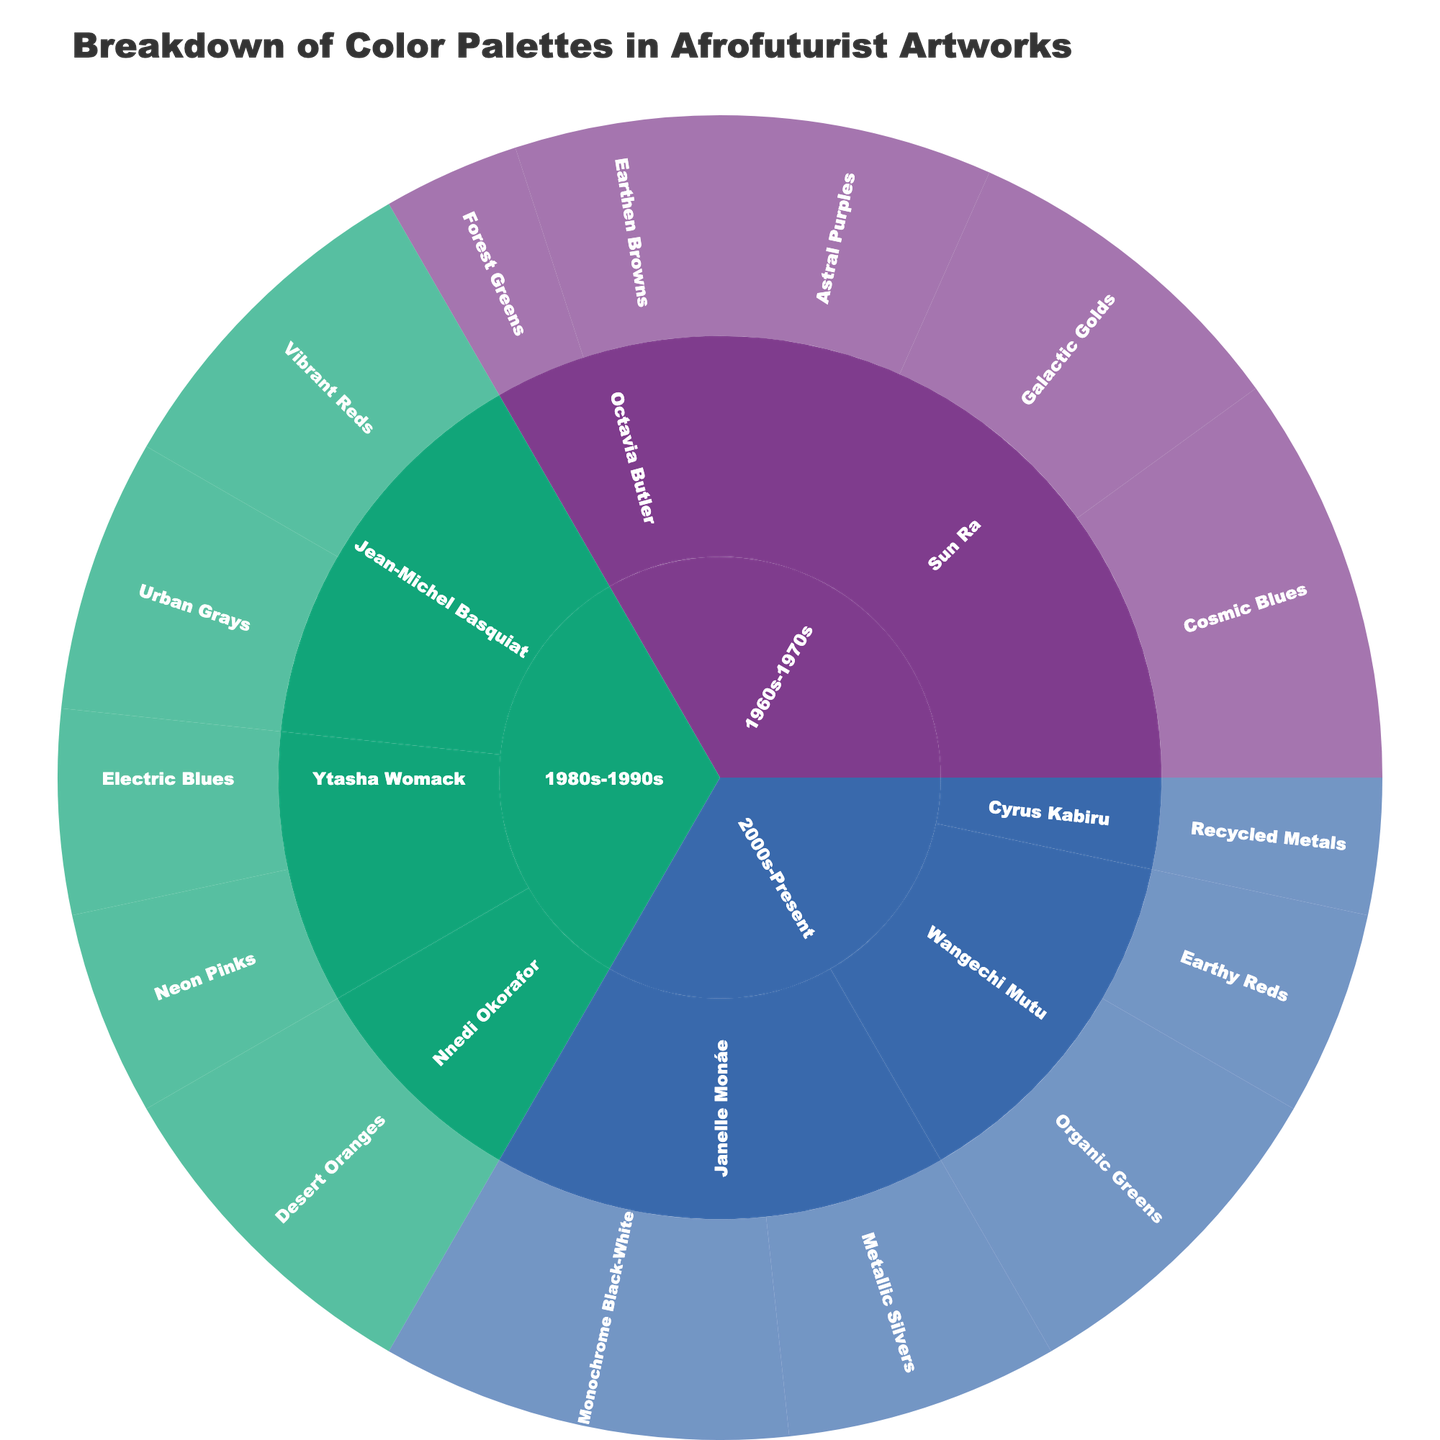What is the title of the figure? The title of the figure appears at the top, and it generally summarizes the main subject of the data visualization. The title reads "Breakdown of Color Palettes in Afrofuturist Artworks".
Answer: Breakdown of Color Palettes in Afrofuturist Artworks Which era has the highest percentage for any single color palette, and what is that percentage? By examining the sunburst plot, we see that the era 2000s-Present with the "Janelle Monáe" influence and "Monochrome Black-White" color palette has the highest percentage, which is 30%.
Answer: 2000s-Present, 30% How many influences contributed color palettes in the 1980s-1990s era? By observing the different sections of the sunburst plot corresponding to 1980s-1990s, we count the distinct influences listed. There are Jean-Michel Basquiat, Ytasha Womack, and Nnedi Okorafor, making it a total of 3.
Answer: 3 What is the combined percentage of the color palettes influenced by Sun Ra in the 1960s-1970s era? From the sunburst plot, we identify the color palettes under Sun Ra for the 1960s-1970s era: Cosmic Blues (30%), Galactic Golds (25%), and Astral Purples (20%). Adding these percentages gives 30 + 25 + 20 = 75%.
Answer: 75% Compare the total percentage of color palettes influenced by Janelle Monáe and Wangechi Mutu in the 2000s-Present era. Which one has a higher total percentage and by how much? For Janelle Monáe: Monochrome Black-White (30%) + Metallic Silvers (20%) = 50%. For Wangechi Mutu: Organic Greens (25%) + Earthy Reds (15%) = 40%. Janelle Monáe has a higher total percentage, with a difference of 50 - 40 = 10%.
Answer: Janelle Monáe, 10% What is the most commonly used color palette in Afrofuturist artworks according to the figure? By reviewing the color palette percentages across all eras and influences, the most frequently occurring color palette with the highest single percentage is "Monochrome Black-White" in the 2000s-Present era with Janelle Monáe, at 30%.
Answer: Monochrome Black-White Which influence has the most diverse set of color palettes, and how many distinct palettes do they have? We determine diversity by counting the number of unique color palettes under each influence. Observing the figure, "Sun Ra" in the 1960s-1970s era has the most diverse set with 3 distinct palettes: Cosmic Blues, Galactic Golds, and Astral Purples.
Answer: Sun Ra, 3 What is the combined percentage of all color palettes influenced by Ytasha Womack across all eras? Checking the portions of the sunburst plot for Ytasha Womack, we see: Neon Pinks (15%) and Electric Blues (15%) in the 1980s-1990s era. Adding these percentages gives 15 + 15 = 30%.
Answer: 30% Describe the relationship between the eras and their dominant influences in terms of color palette variety. By looking at the sunburst plot, we observe that earlier eras (1960s-1970s) had fewer, but more varied dominant influences like Sun Ra, while the 2000s-Present era shows more individual influences, each with fewer palettes.
Answer: Earlier eras have fewer but more varied influences; recent eras have more individual influences with fewer palettes each 